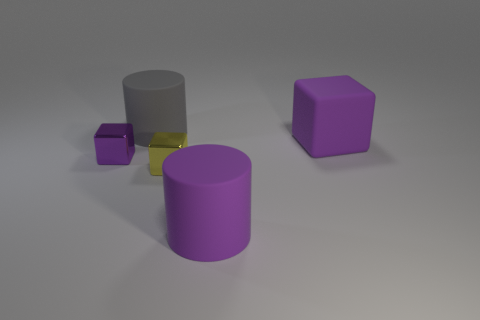Add 1 yellow metallic objects. How many objects exist? 6 Subtract all blocks. How many objects are left? 2 Subtract 0 green balls. How many objects are left? 5 Subtract all gray cylinders. Subtract all tiny yellow metallic objects. How many objects are left? 3 Add 5 tiny yellow objects. How many tiny yellow objects are left? 6 Add 4 blocks. How many blocks exist? 7 